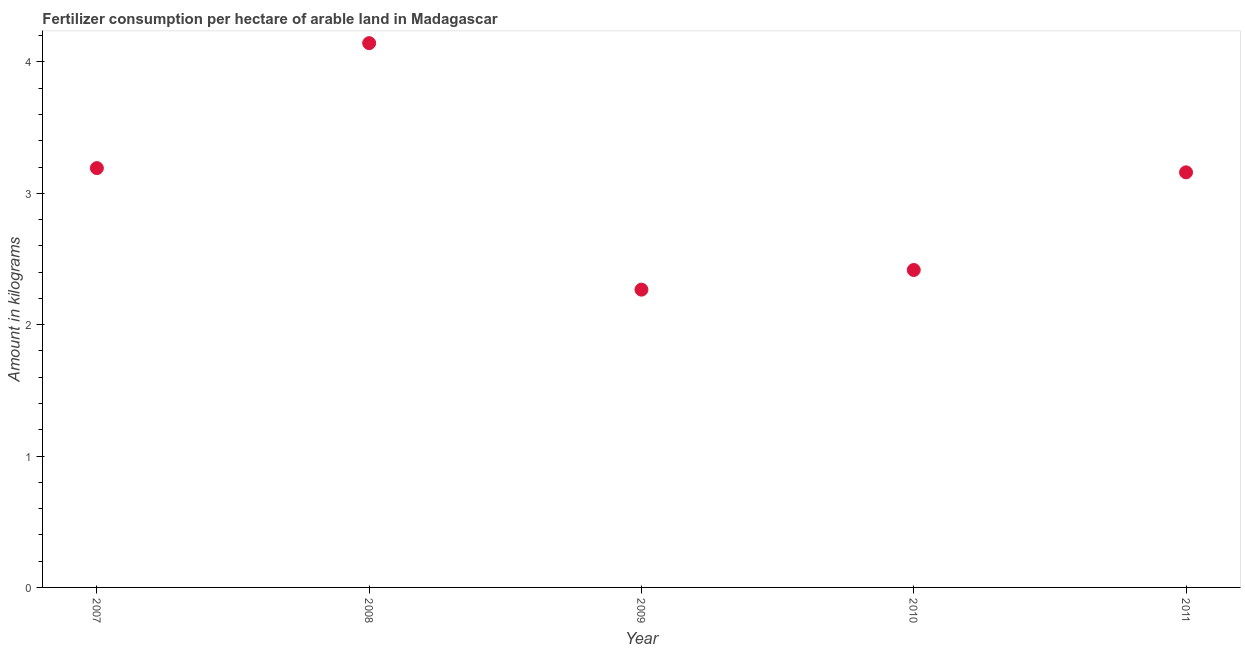What is the amount of fertilizer consumption in 2007?
Make the answer very short. 3.19. Across all years, what is the maximum amount of fertilizer consumption?
Ensure brevity in your answer.  4.14. Across all years, what is the minimum amount of fertilizer consumption?
Your answer should be very brief. 2.27. In which year was the amount of fertilizer consumption maximum?
Make the answer very short. 2008. What is the sum of the amount of fertilizer consumption?
Keep it short and to the point. 15.18. What is the difference between the amount of fertilizer consumption in 2007 and 2011?
Provide a succinct answer. 0.03. What is the average amount of fertilizer consumption per year?
Your answer should be compact. 3.04. What is the median amount of fertilizer consumption?
Make the answer very short. 3.16. In how many years, is the amount of fertilizer consumption greater than 2 kg?
Provide a short and direct response. 5. Do a majority of the years between 2009 and 2007 (inclusive) have amount of fertilizer consumption greater than 3.4 kg?
Your answer should be very brief. No. What is the ratio of the amount of fertilizer consumption in 2007 to that in 2011?
Your answer should be compact. 1.01. Is the amount of fertilizer consumption in 2009 less than that in 2010?
Your response must be concise. Yes. What is the difference between the highest and the second highest amount of fertilizer consumption?
Keep it short and to the point. 0.95. Is the sum of the amount of fertilizer consumption in 2010 and 2011 greater than the maximum amount of fertilizer consumption across all years?
Your answer should be very brief. Yes. What is the difference between the highest and the lowest amount of fertilizer consumption?
Keep it short and to the point. 1.88. In how many years, is the amount of fertilizer consumption greater than the average amount of fertilizer consumption taken over all years?
Ensure brevity in your answer.  3. Are the values on the major ticks of Y-axis written in scientific E-notation?
Provide a short and direct response. No. Does the graph contain grids?
Offer a terse response. No. What is the title of the graph?
Offer a very short reply. Fertilizer consumption per hectare of arable land in Madagascar . What is the label or title of the X-axis?
Make the answer very short. Year. What is the label or title of the Y-axis?
Your answer should be very brief. Amount in kilograms. What is the Amount in kilograms in 2007?
Your answer should be compact. 3.19. What is the Amount in kilograms in 2008?
Ensure brevity in your answer.  4.14. What is the Amount in kilograms in 2009?
Offer a terse response. 2.27. What is the Amount in kilograms in 2010?
Your response must be concise. 2.42. What is the Amount in kilograms in 2011?
Provide a short and direct response. 3.16. What is the difference between the Amount in kilograms in 2007 and 2008?
Your response must be concise. -0.95. What is the difference between the Amount in kilograms in 2007 and 2009?
Give a very brief answer. 0.93. What is the difference between the Amount in kilograms in 2007 and 2010?
Make the answer very short. 0.78. What is the difference between the Amount in kilograms in 2007 and 2011?
Your answer should be compact. 0.03. What is the difference between the Amount in kilograms in 2008 and 2009?
Keep it short and to the point. 1.88. What is the difference between the Amount in kilograms in 2008 and 2010?
Provide a short and direct response. 1.73. What is the difference between the Amount in kilograms in 2008 and 2011?
Ensure brevity in your answer.  0.98. What is the difference between the Amount in kilograms in 2009 and 2010?
Your response must be concise. -0.15. What is the difference between the Amount in kilograms in 2009 and 2011?
Your response must be concise. -0.89. What is the difference between the Amount in kilograms in 2010 and 2011?
Make the answer very short. -0.74. What is the ratio of the Amount in kilograms in 2007 to that in 2008?
Ensure brevity in your answer.  0.77. What is the ratio of the Amount in kilograms in 2007 to that in 2009?
Provide a short and direct response. 1.41. What is the ratio of the Amount in kilograms in 2007 to that in 2010?
Offer a terse response. 1.32. What is the ratio of the Amount in kilograms in 2008 to that in 2009?
Keep it short and to the point. 1.83. What is the ratio of the Amount in kilograms in 2008 to that in 2010?
Your answer should be compact. 1.72. What is the ratio of the Amount in kilograms in 2008 to that in 2011?
Offer a terse response. 1.31. What is the ratio of the Amount in kilograms in 2009 to that in 2010?
Keep it short and to the point. 0.94. What is the ratio of the Amount in kilograms in 2009 to that in 2011?
Your answer should be compact. 0.72. What is the ratio of the Amount in kilograms in 2010 to that in 2011?
Keep it short and to the point. 0.77. 